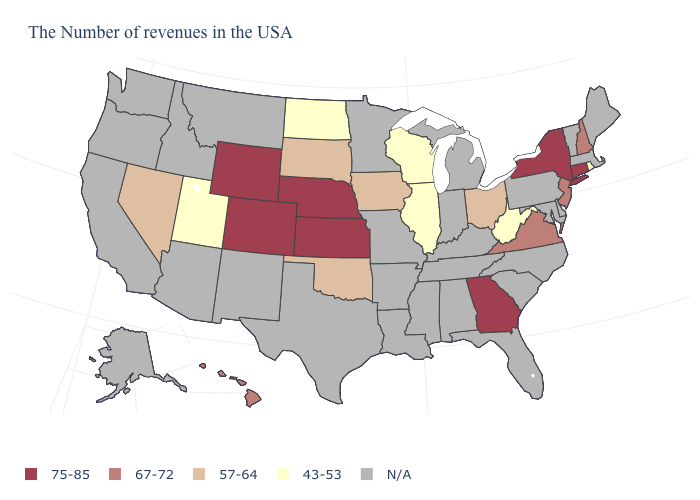Name the states that have a value in the range N/A?
Answer briefly. Maine, Massachusetts, Vermont, Delaware, Maryland, Pennsylvania, North Carolina, South Carolina, Florida, Michigan, Kentucky, Indiana, Alabama, Tennessee, Mississippi, Louisiana, Missouri, Arkansas, Minnesota, Texas, New Mexico, Montana, Arizona, Idaho, California, Washington, Oregon, Alaska. How many symbols are there in the legend?
Quick response, please. 5. What is the lowest value in the USA?
Quick response, please. 43-53. Does the map have missing data?
Write a very short answer. Yes. Which states have the lowest value in the West?
Concise answer only. Utah. Name the states that have a value in the range N/A?
Answer briefly. Maine, Massachusetts, Vermont, Delaware, Maryland, Pennsylvania, North Carolina, South Carolina, Florida, Michigan, Kentucky, Indiana, Alabama, Tennessee, Mississippi, Louisiana, Missouri, Arkansas, Minnesota, Texas, New Mexico, Montana, Arizona, Idaho, California, Washington, Oregon, Alaska. Among the states that border South Carolina , which have the lowest value?
Short answer required. Georgia. What is the highest value in states that border Tennessee?
Quick response, please. 75-85. What is the value of Illinois?
Answer briefly. 43-53. What is the lowest value in the USA?
Write a very short answer. 43-53. What is the value of West Virginia?
Concise answer only. 43-53. What is the value of Washington?
Give a very brief answer. N/A. Is the legend a continuous bar?
Give a very brief answer. No. Does Rhode Island have the lowest value in the USA?
Quick response, please. Yes. 